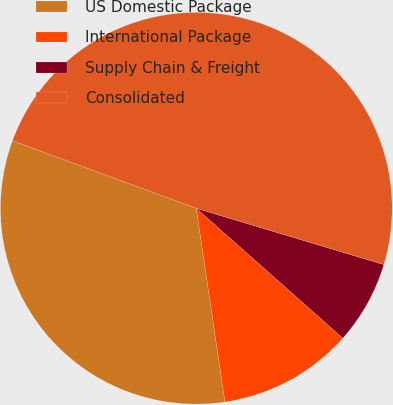Convert chart. <chart><loc_0><loc_0><loc_500><loc_500><pie_chart><fcel>US Domestic Package<fcel>International Package<fcel>Supply Chain & Freight<fcel>Consolidated<nl><fcel>32.95%<fcel>11.12%<fcel>6.9%<fcel>49.04%<nl></chart> 